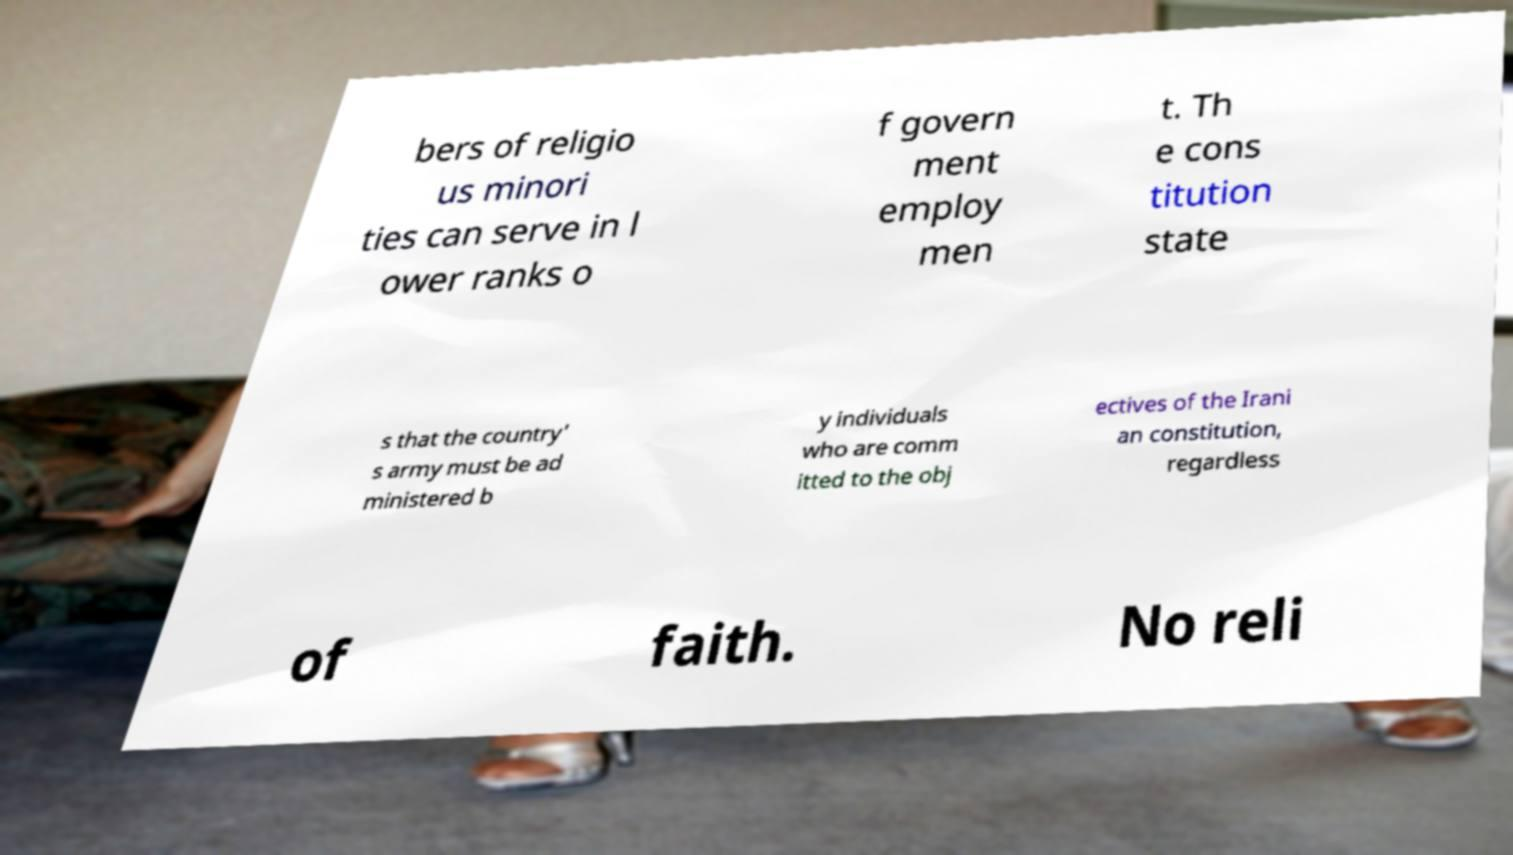What messages or text are displayed in this image? I need them in a readable, typed format. bers of religio us minori ties can serve in l ower ranks o f govern ment employ men t. Th e cons titution state s that the country' s army must be ad ministered b y individuals who are comm itted to the obj ectives of the Irani an constitution, regardless of faith. No reli 